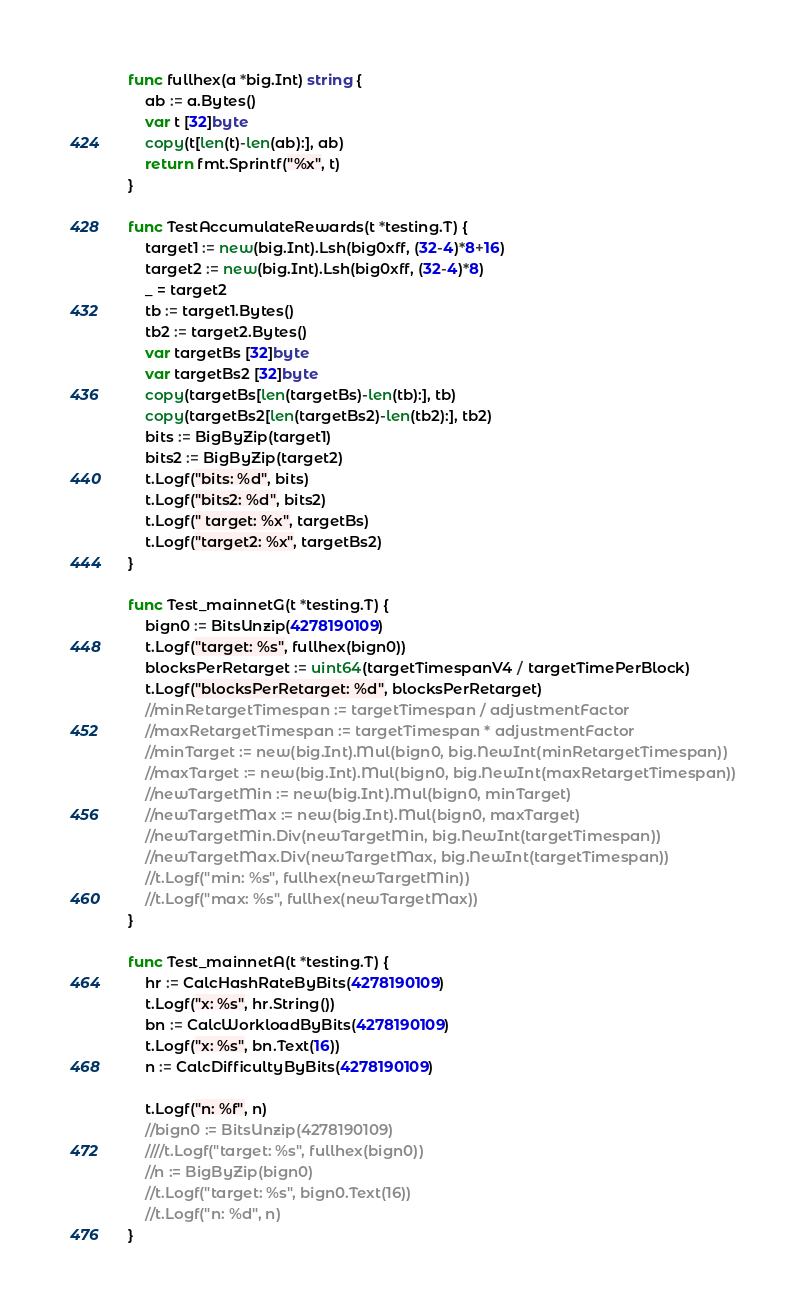<code> <loc_0><loc_0><loc_500><loc_500><_Go_>func fullhex(a *big.Int) string {
	ab := a.Bytes()
	var t [32]byte
	copy(t[len(t)-len(ab):], ab)
	return fmt.Sprintf("%x", t)
}

func TestAccumulateRewards(t *testing.T) {
	target1 := new(big.Int).Lsh(big0xff, (32-4)*8+16)
	target2 := new(big.Int).Lsh(big0xff, (32-4)*8)
	_ = target2
	tb := target1.Bytes()
	tb2 := target2.Bytes()
	var targetBs [32]byte
	var targetBs2 [32]byte
	copy(targetBs[len(targetBs)-len(tb):], tb)
	copy(targetBs2[len(targetBs2)-len(tb2):], tb2)
	bits := BigByZip(target1)
	bits2 := BigByZip(target2)
	t.Logf("bits: %d", bits)
	t.Logf("bits2: %d", bits2)
	t.Logf(" target: %x", targetBs)
	t.Logf("target2: %x", targetBs2)
}

func Test_mainnetG(t *testing.T) {
	bign0 := BitsUnzip(4278190109)
	t.Logf("target: %s", fullhex(bign0))
	blocksPerRetarget := uint64(targetTimespanV4 / targetTimePerBlock)
	t.Logf("blocksPerRetarget: %d", blocksPerRetarget)
	//minRetargetTimespan := targetTimespan / adjustmentFactor
	//maxRetargetTimespan := targetTimespan * adjustmentFactor
	//minTarget := new(big.Int).Mul(bign0, big.NewInt(minRetargetTimespan))
	//maxTarget := new(big.Int).Mul(bign0, big.NewInt(maxRetargetTimespan))
	//newTargetMin := new(big.Int).Mul(bign0, minTarget)
	//newTargetMax := new(big.Int).Mul(bign0, maxTarget)
	//newTargetMin.Div(newTargetMin, big.NewInt(targetTimespan))
	//newTargetMax.Div(newTargetMax, big.NewInt(targetTimespan))
	//t.Logf("min: %s", fullhex(newTargetMin))
	//t.Logf("max: %s", fullhex(newTargetMax))
}

func Test_mainnetA(t *testing.T) {
	hr := CalcHashRateByBits(4278190109)
	t.Logf("x: %s", hr.String())
	bn := CalcWorkloadByBits(4278190109)
	t.Logf("x: %s", bn.Text(16))
	n := CalcDifficultyByBits(4278190109)

	t.Logf("n: %f", n)
	//bign0 := BitsUnzip(4278190109)
	////t.Logf("target: %s", fullhex(bign0))
	//n := BigByZip(bign0)
	//t.Logf("target: %s", bign0.Text(16))
	//t.Logf("n: %d", n)
}
</code> 